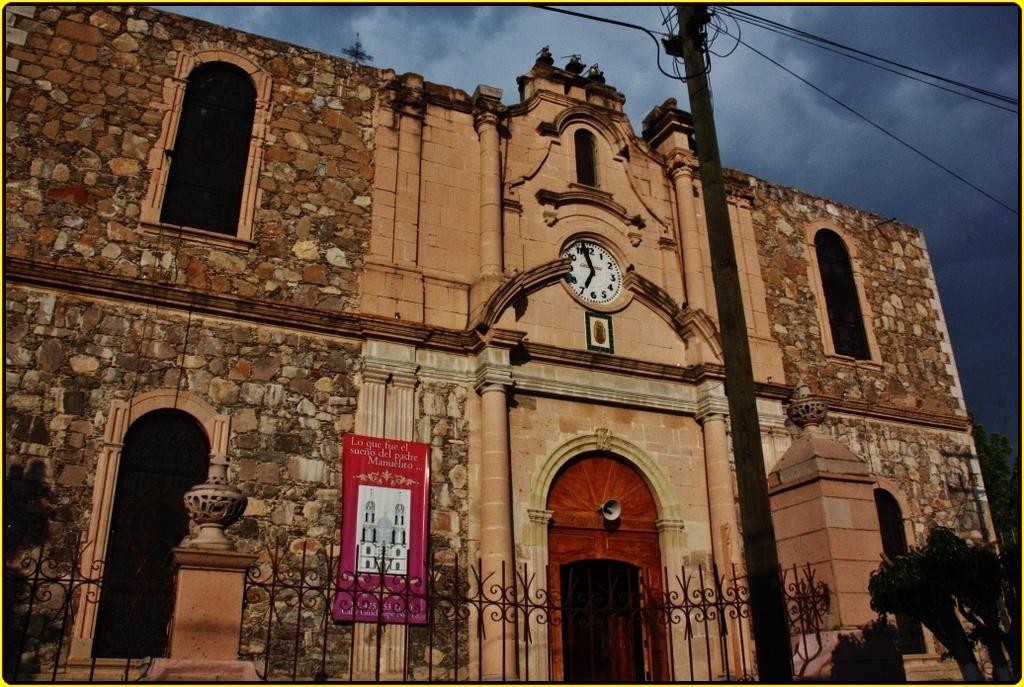What is the time on the clock?
Offer a very short reply. 6:57. 